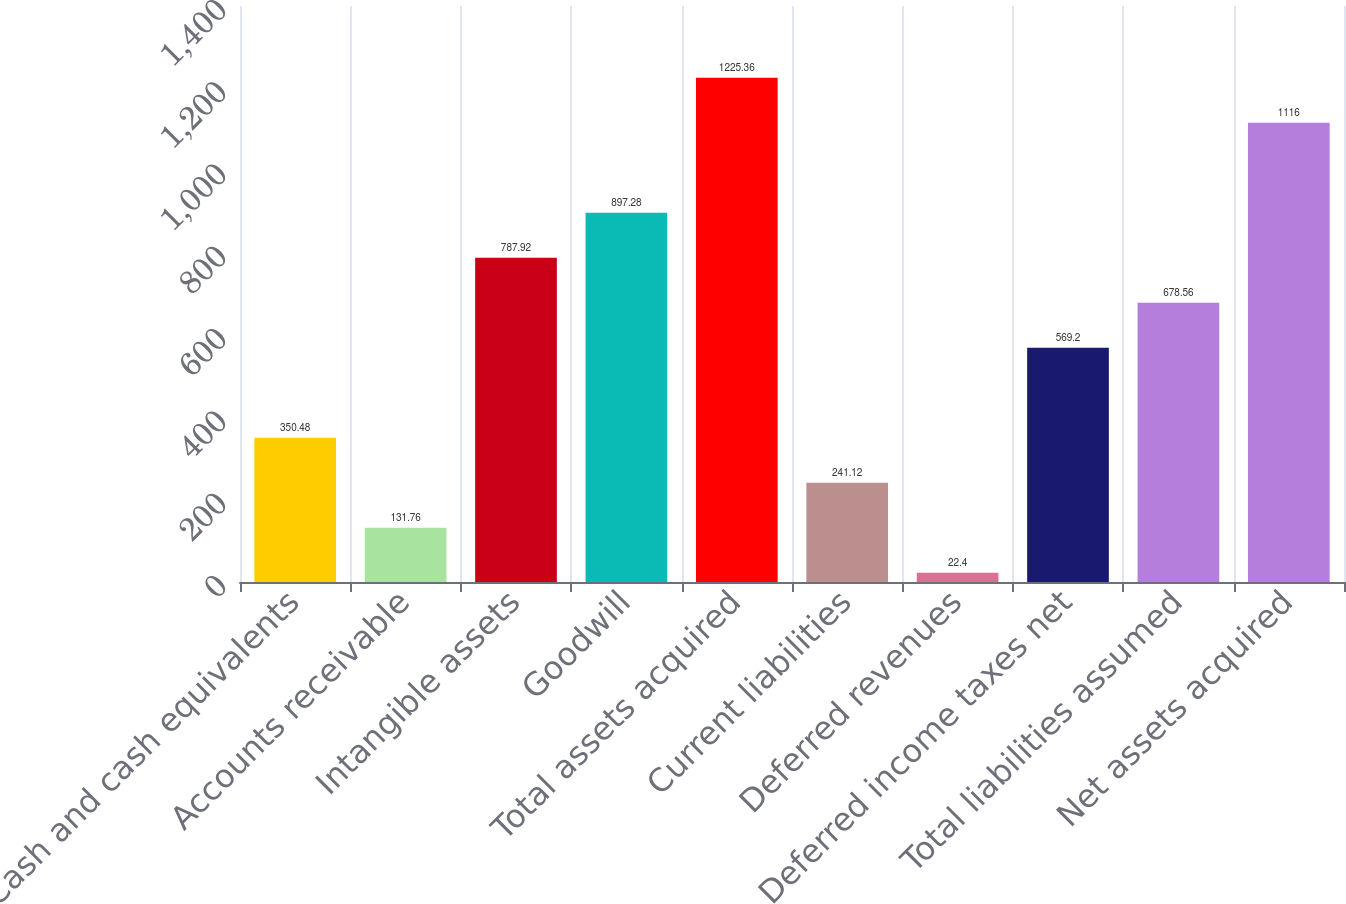Convert chart. <chart><loc_0><loc_0><loc_500><loc_500><bar_chart><fcel>Cash and cash equivalents<fcel>Accounts receivable<fcel>Intangible assets<fcel>Goodwill<fcel>Total assets acquired<fcel>Current liabilities<fcel>Deferred revenues<fcel>Deferred income taxes net<fcel>Total liabilities assumed<fcel>Net assets acquired<nl><fcel>350.48<fcel>131.76<fcel>787.92<fcel>897.28<fcel>1225.36<fcel>241.12<fcel>22.4<fcel>569.2<fcel>678.56<fcel>1116<nl></chart> 